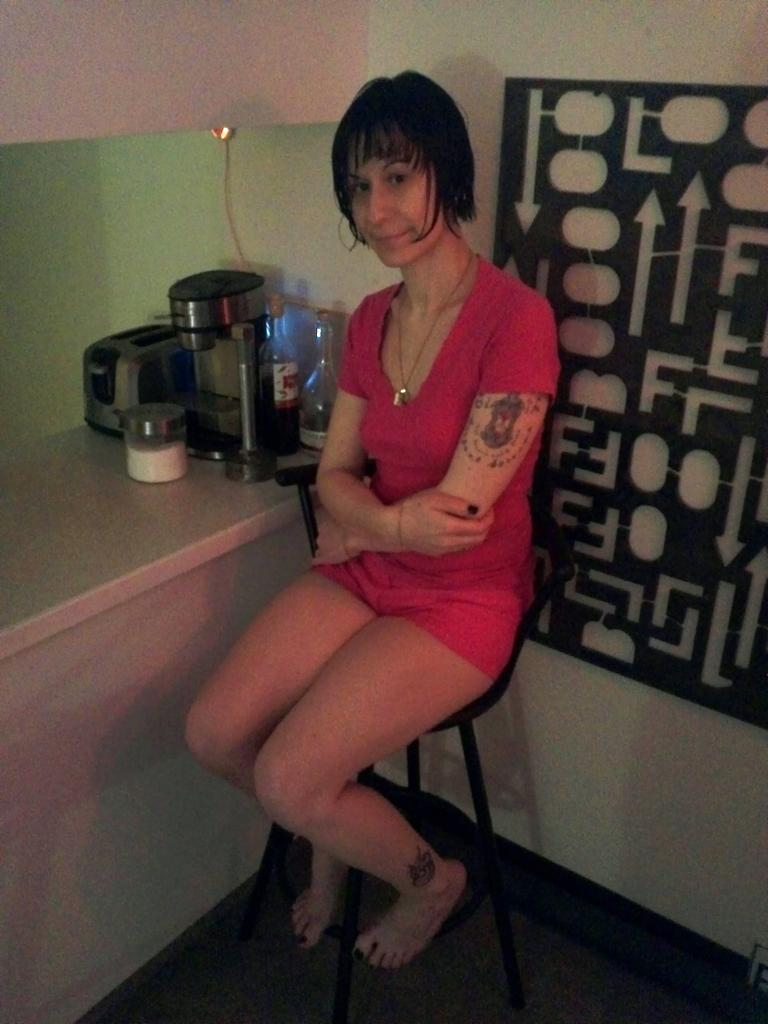What is the woman in the image doing? The woman is sitting in the image. What is the woman wearing around her neck? The woman is wearing a necklace. What color is the dress the woman is wearing? The woman is wearing a red dress. What can be seen in the background of the image? There are bottles and other unspecified items visible in the background of the image. What type of pets can be seen playing with the smoke in the image? There are no pets or smoke present in the image. What is the woman drinking in the image? The provided facts do not mention any drinks or beverages in the image. 